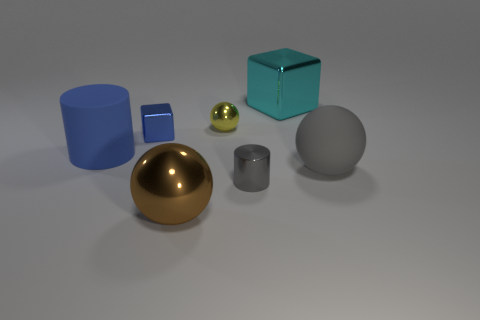Can you describe the lighting and shadows in this image? Certainly. The image features soft, diffused lighting that creates gentle shadows beneath each object. The shadows are slightly elongated, suggesting a light source positioned above and to the right of the scene. This lighting gives the composition a calm and even tone, with shadows that help define the spatial relationships between the objects. 